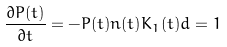Convert formula to latex. <formula><loc_0><loc_0><loc_500><loc_500>\frac { \partial P ( t ) } { \partial t } = - P ( t ) n ( t ) K _ { 1 } ( t ) d = 1</formula> 